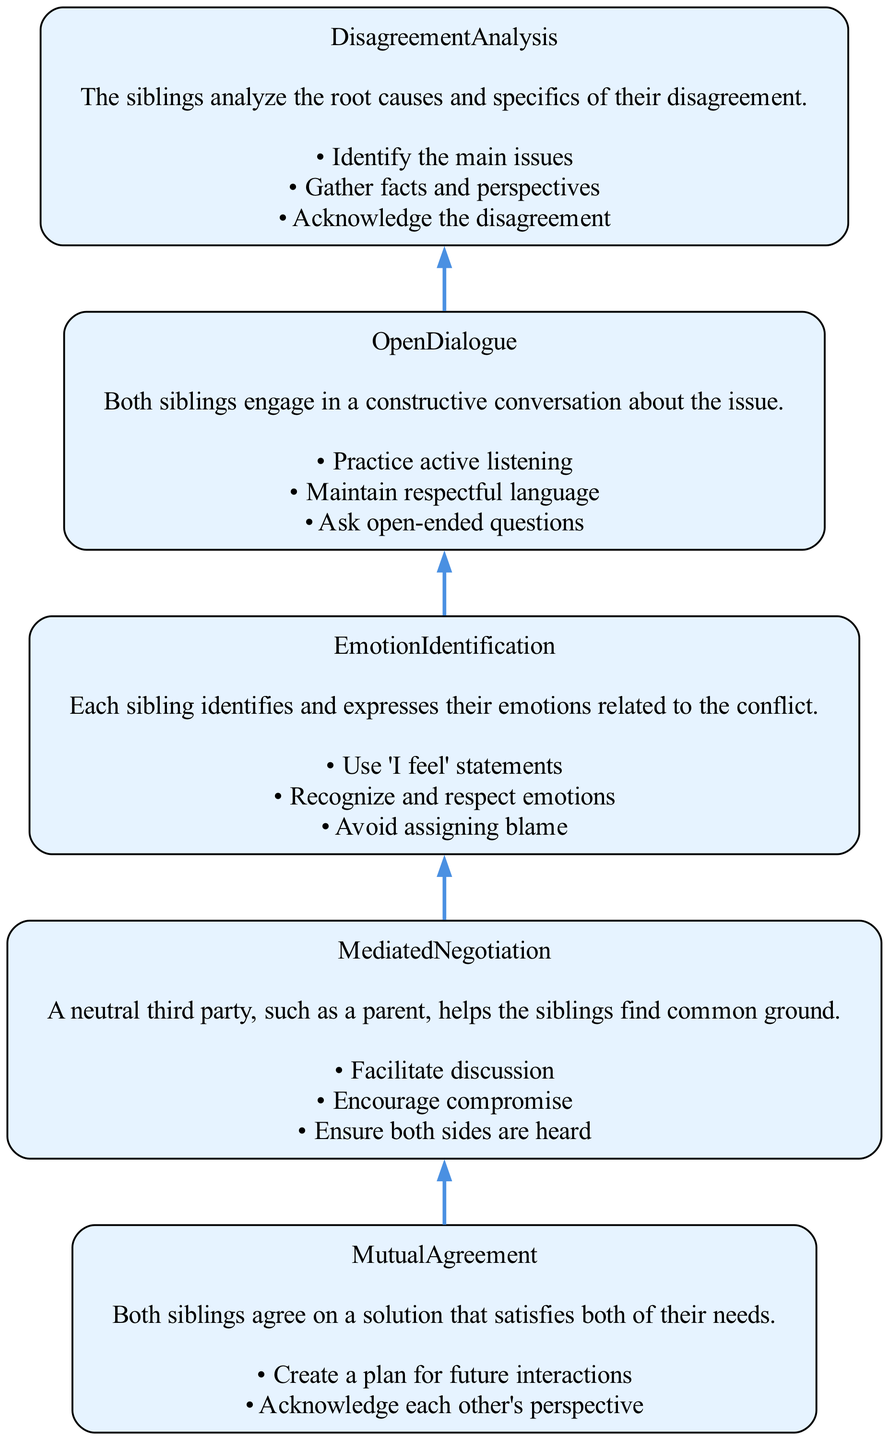What is the first step in the conflict resolution process? The diagram indicates that the first step is "Disagreement Analysis," which appears at the bottom of the flow chart. This step starts the process of resolving the conflict.
Answer: Disagreement Analysis How many key actions are listed for Emotion Identification? By examining the "Emotion Identification" node in the flow chart, it is shown that there are three key actions listed under this step.
Answer: 3 Which node comes directly after Open Dialogue? In the flow from the bottom to the top of the diagram, "Emotion Identification" follows "Open Dialogue" as the next step in the conflict resolution process.
Answer: Emotion Identification What are two key actions in Mediated Negotiation? Upon reviewing the "Mediated Negotiation" section of the diagram, two key actions identified there are "Encourage compromise" and "Ensure both sides are heard."
Answer: Encourage compromise, Ensure both sides are heard Which specific step involves expressing feelings using 'I feel' statements? The "Emotion Identification" node specifies that one of the key actions in that step is to "Use 'I feel' statements," making it clear that this step focuses on expressing personal emotions.
Answer: Emotion Identification What is the overall purpose of the Healthy Conflict Resolution Process? By tracking the flow of the diagram from "Disagreement Analysis" to "Mutual Agreement," it becomes evident that the purpose is to resolve conflicts constructively between siblings by following these steps.
Answer: Resolve conflicts constructively What is the last step in the conflict resolution process? The diagram clearly presents "Mutual Agreement" at the top, indicating that it is the final step where both siblings reach a satisfying resolution to their disagreement.
Answer: Mutual Agreement How many total steps are in the Healthy Conflict Resolution Process? Counting each node in the flow chart from the bottom to the top reveals that there are five distinct steps present within this conflict resolution process.
Answer: 5 What aspect of the resolution process does Open Dialogue focus on? The "Open Dialogue" step is defined as a constructive conversation about the issue, emphasizing the need for respectful communication and active listening between siblings.
Answer: Constructive conversation 